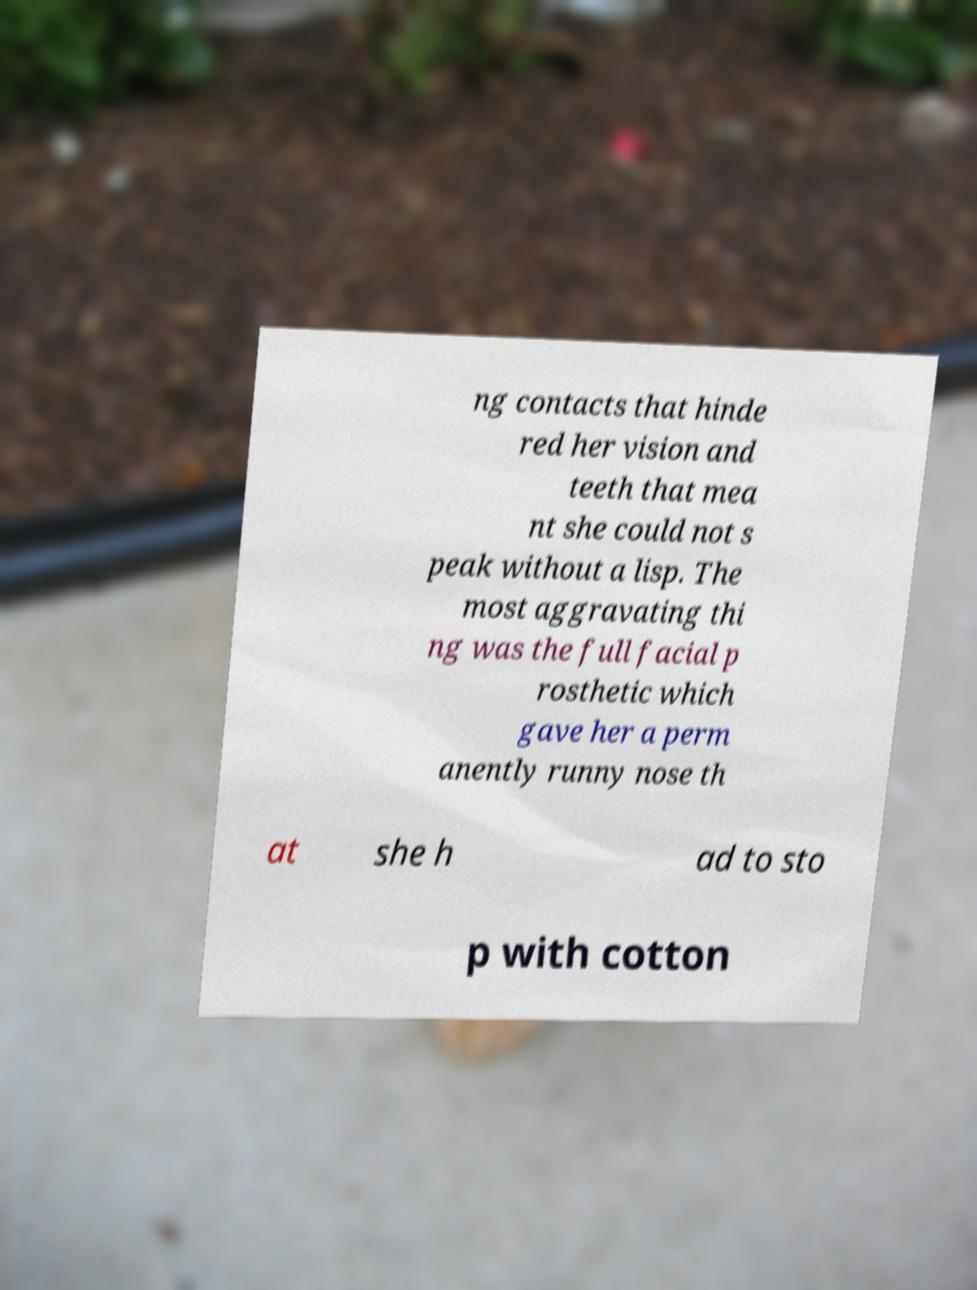Please read and relay the text visible in this image. What does it say? ng contacts that hinde red her vision and teeth that mea nt she could not s peak without a lisp. The most aggravating thi ng was the full facial p rosthetic which gave her a perm anently runny nose th at she h ad to sto p with cotton 